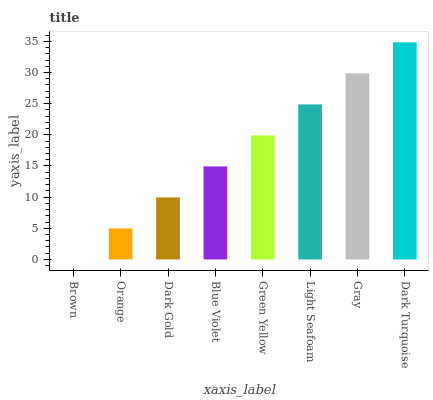Is Brown the minimum?
Answer yes or no. Yes. Is Dark Turquoise the maximum?
Answer yes or no. Yes. Is Orange the minimum?
Answer yes or no. No. Is Orange the maximum?
Answer yes or no. No. Is Orange greater than Brown?
Answer yes or no. Yes. Is Brown less than Orange?
Answer yes or no. Yes. Is Brown greater than Orange?
Answer yes or no. No. Is Orange less than Brown?
Answer yes or no. No. Is Green Yellow the high median?
Answer yes or no. Yes. Is Blue Violet the low median?
Answer yes or no. Yes. Is Orange the high median?
Answer yes or no. No. Is Green Yellow the low median?
Answer yes or no. No. 